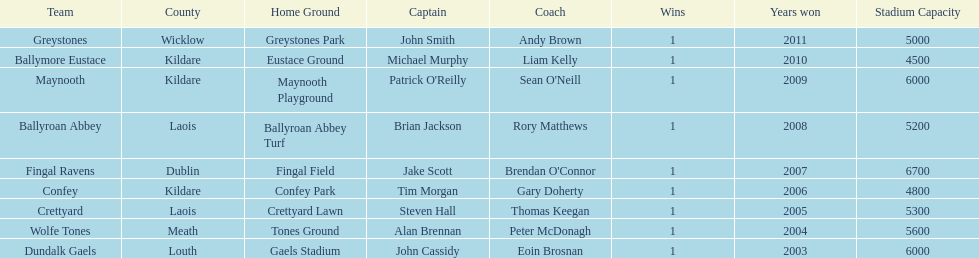Which team won previous to crettyard? Wolfe Tones. 